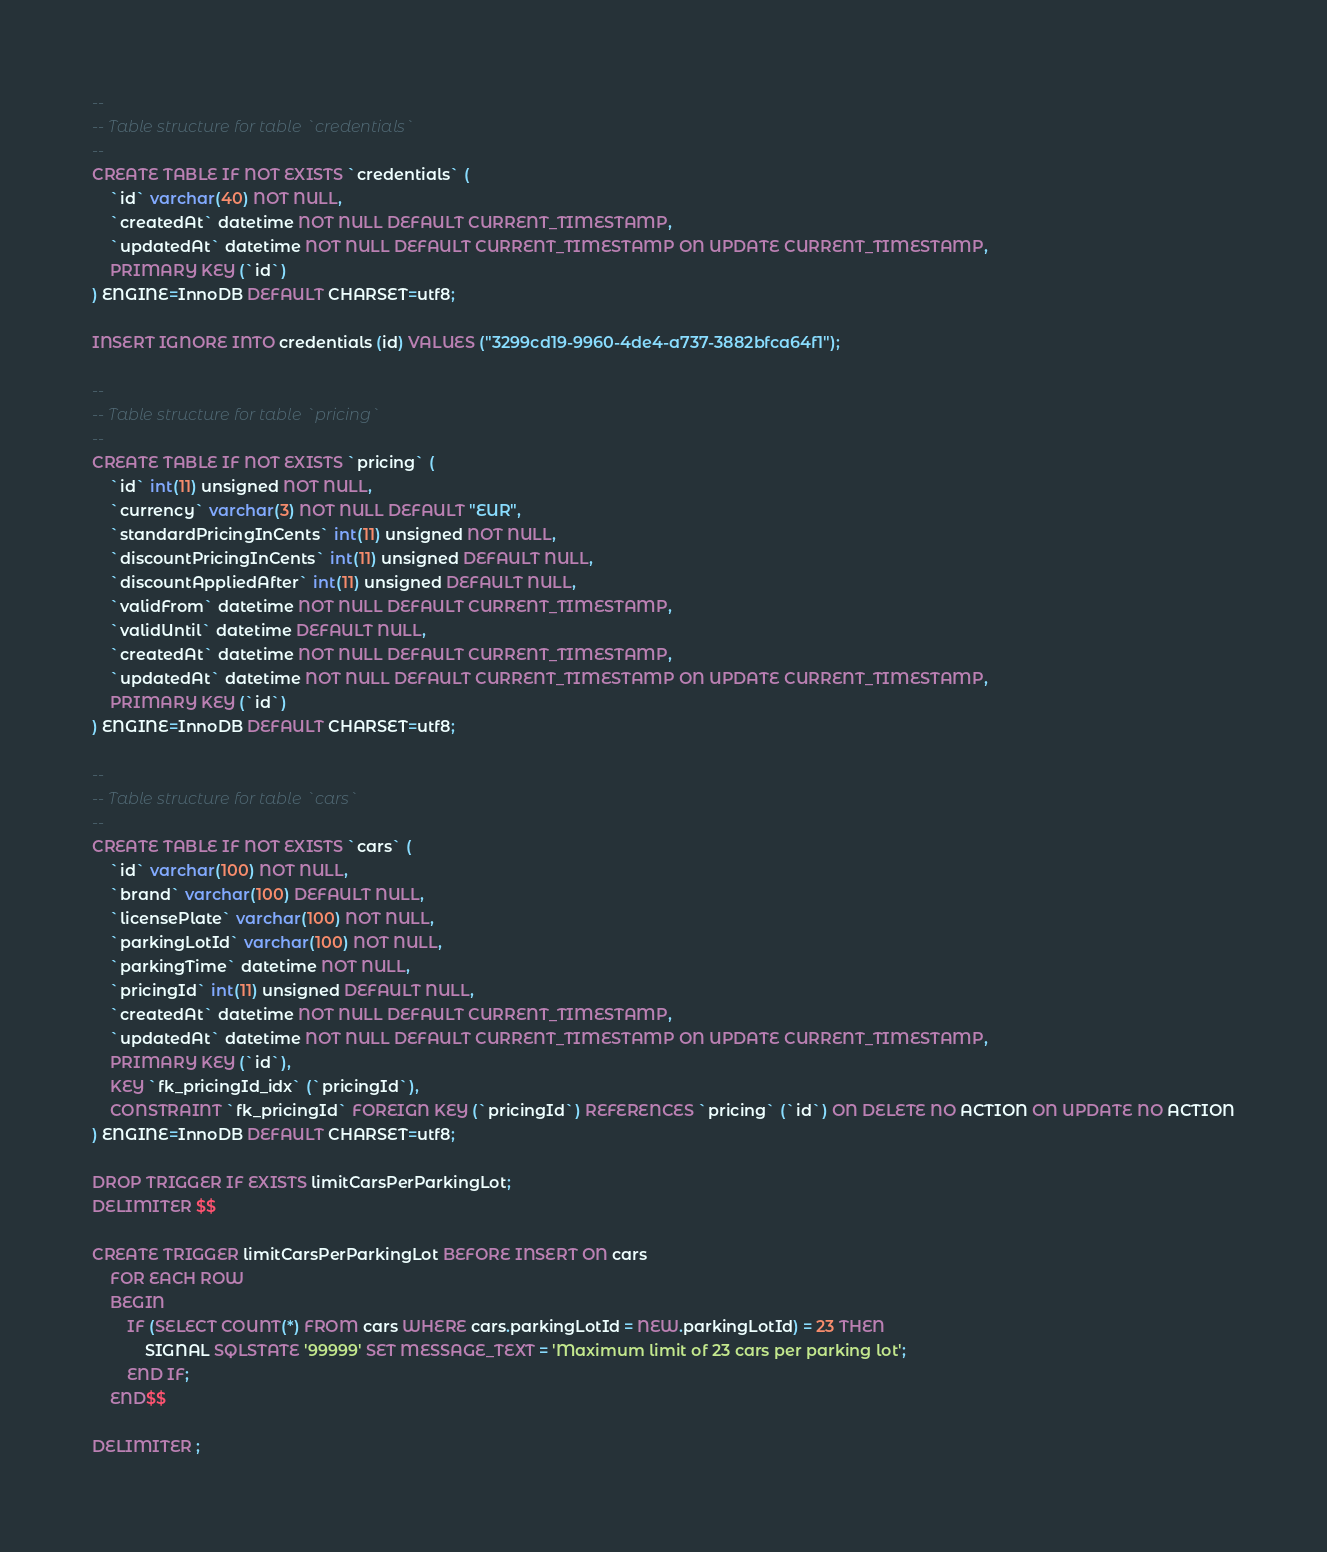<code> <loc_0><loc_0><loc_500><loc_500><_SQL_>--
-- Table structure for table `credentials`
--
CREATE TABLE IF NOT EXISTS `credentials` (
    `id` varchar(40) NOT NULL,
    `createdAt` datetime NOT NULL DEFAULT CURRENT_TIMESTAMP,
    `updatedAt` datetime NOT NULL DEFAULT CURRENT_TIMESTAMP ON UPDATE CURRENT_TIMESTAMP,
    PRIMARY KEY (`id`)
) ENGINE=InnoDB DEFAULT CHARSET=utf8;

INSERT IGNORE INTO credentials (id) VALUES ("3299cd19-9960-4de4-a737-3882bfca64f1");

--
-- Table structure for table `pricing`
--
CREATE TABLE IF NOT EXISTS `pricing` (
    `id` int(11) unsigned NOT NULL,
    `currency` varchar(3) NOT NULL DEFAULT "EUR",
    `standardPricingInCents` int(11) unsigned NOT NULL,
    `discountPricingInCents` int(11) unsigned DEFAULT NULL,
    `discountAppliedAfter` int(11) unsigned DEFAULT NULL,
    `validFrom` datetime NOT NULL DEFAULT CURRENT_TIMESTAMP,
    `validUntil` datetime DEFAULT NULL,
    `createdAt` datetime NOT NULL DEFAULT CURRENT_TIMESTAMP,
    `updatedAt` datetime NOT NULL DEFAULT CURRENT_TIMESTAMP ON UPDATE CURRENT_TIMESTAMP,
    PRIMARY KEY (`id`)
) ENGINE=InnoDB DEFAULT CHARSET=utf8;

--
-- Table structure for table `cars`
--
CREATE TABLE IF NOT EXISTS `cars` (
    `id` varchar(100) NOT NULL,
    `brand` varchar(100) DEFAULT NULL,
    `licensePlate` varchar(100) NOT NULL,
    `parkingLotId` varchar(100) NOT NULL,
    `parkingTime` datetime NOT NULL,
    `pricingId` int(11) unsigned DEFAULT NULL,
    `createdAt` datetime NOT NULL DEFAULT CURRENT_TIMESTAMP,
    `updatedAt` datetime NOT NULL DEFAULT CURRENT_TIMESTAMP ON UPDATE CURRENT_TIMESTAMP,
    PRIMARY KEY (`id`),
    KEY `fk_pricingId_idx` (`pricingId`),
    CONSTRAINT `fk_pricingId` FOREIGN KEY (`pricingId`) REFERENCES `pricing` (`id`) ON DELETE NO ACTION ON UPDATE NO ACTION
) ENGINE=InnoDB DEFAULT CHARSET=utf8;

DROP TRIGGER IF EXISTS limitCarsPerParkingLot;
DELIMITER $$

CREATE TRIGGER limitCarsPerParkingLot BEFORE INSERT ON cars
    FOR EACH ROW
    BEGIN
        IF (SELECT COUNT(*) FROM cars WHERE cars.parkingLotId = NEW.parkingLotId) = 23 THEN
            SIGNAL SQLSTATE '99999' SET MESSAGE_TEXT = 'Maximum limit of 23 cars per parking lot';
        END IF;
    END$$

DELIMITER ;
</code> 